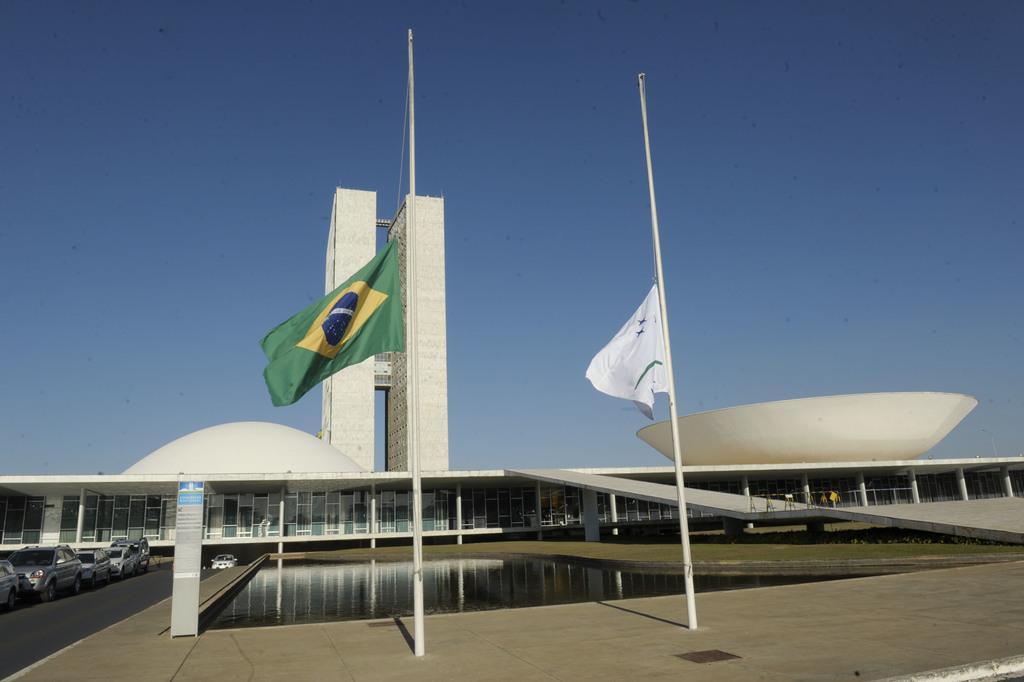Please provide a concise description of this image. In this image we can see the flags to the poles. We can also see the water, grass, some people standing, a building with pillars, aboard, a tower and the sky which looks cloudy. On the left side we can see a group of cars on the ground. 